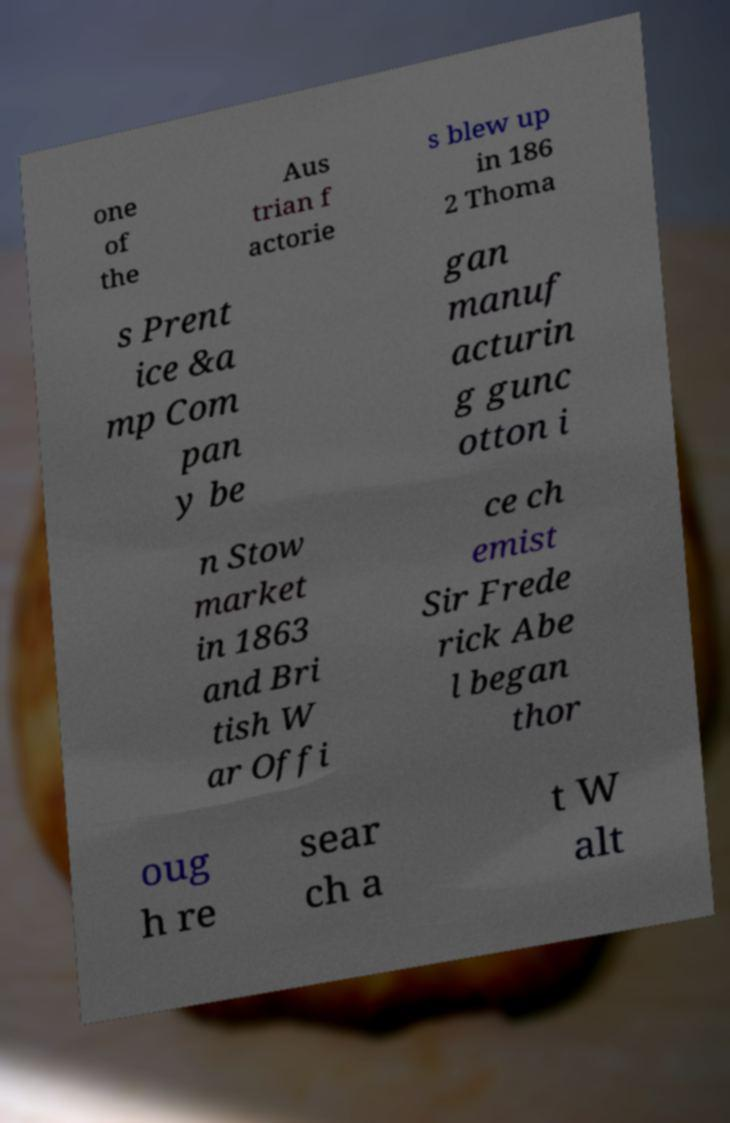Could you assist in decoding the text presented in this image and type it out clearly? one of the Aus trian f actorie s blew up in 186 2 Thoma s Prent ice &a mp Com pan y be gan manuf acturin g gunc otton i n Stow market in 1863 and Bri tish W ar Offi ce ch emist Sir Frede rick Abe l began thor oug h re sear ch a t W alt 